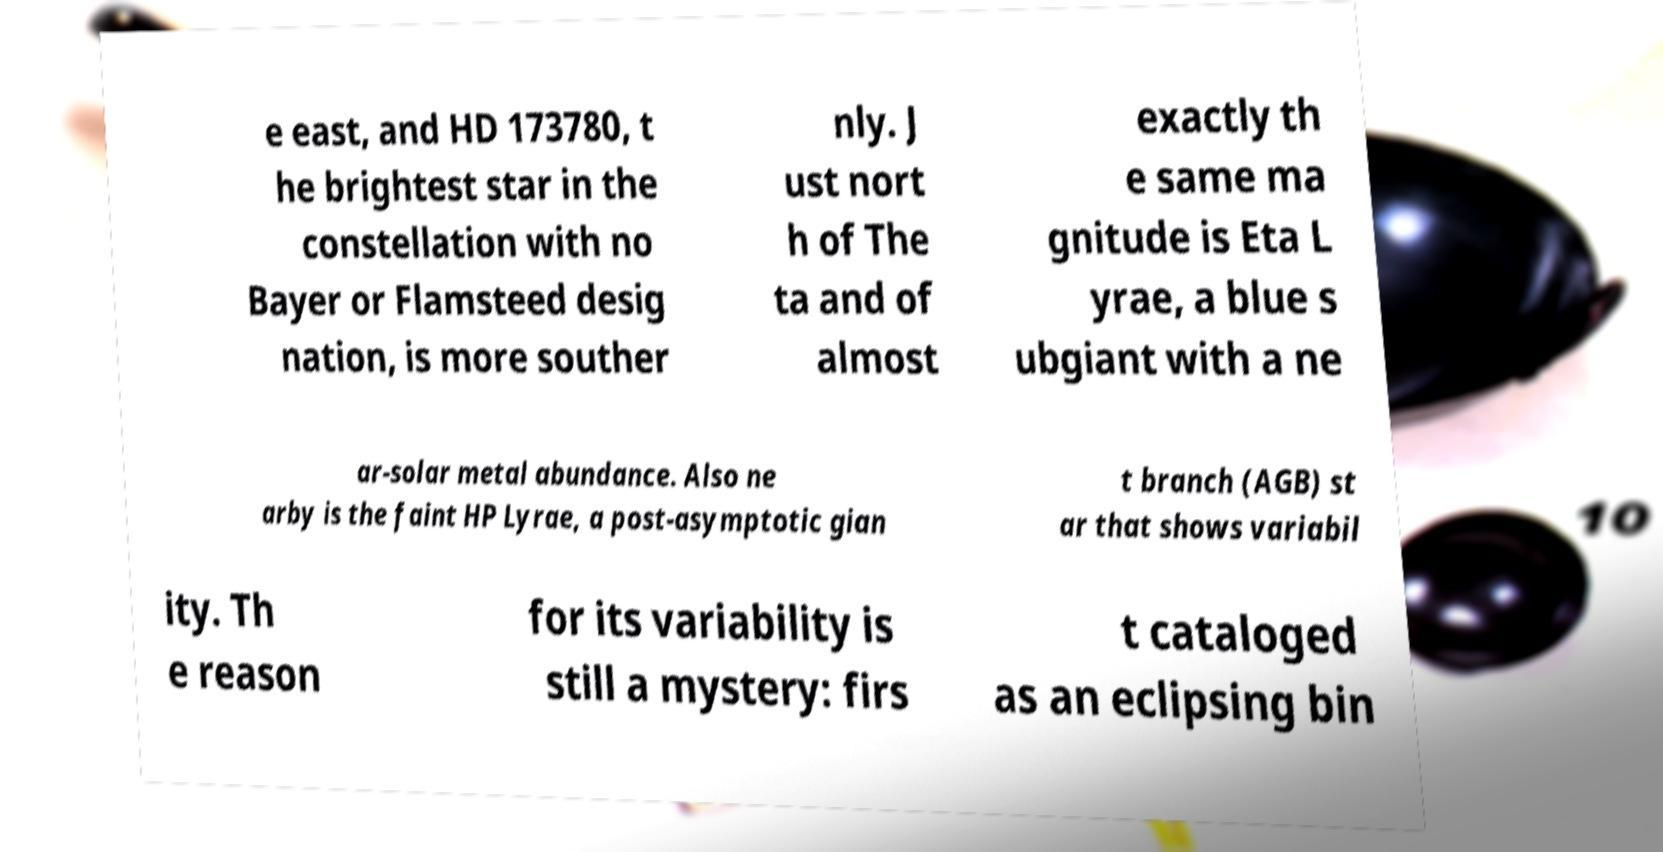There's text embedded in this image that I need extracted. Can you transcribe it verbatim? e east, and HD 173780, t he brightest star in the constellation with no Bayer or Flamsteed desig nation, is more souther nly. J ust nort h of The ta and of almost exactly th e same ma gnitude is Eta L yrae, a blue s ubgiant with a ne ar-solar metal abundance. Also ne arby is the faint HP Lyrae, a post-asymptotic gian t branch (AGB) st ar that shows variabil ity. Th e reason for its variability is still a mystery: firs t cataloged as an eclipsing bin 